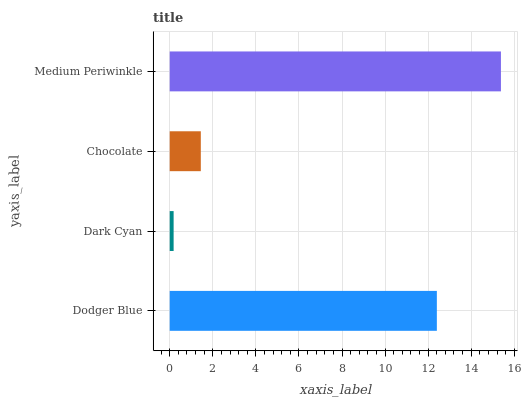Is Dark Cyan the minimum?
Answer yes or no. Yes. Is Medium Periwinkle the maximum?
Answer yes or no. Yes. Is Chocolate the minimum?
Answer yes or no. No. Is Chocolate the maximum?
Answer yes or no. No. Is Chocolate greater than Dark Cyan?
Answer yes or no. Yes. Is Dark Cyan less than Chocolate?
Answer yes or no. Yes. Is Dark Cyan greater than Chocolate?
Answer yes or no. No. Is Chocolate less than Dark Cyan?
Answer yes or no. No. Is Dodger Blue the high median?
Answer yes or no. Yes. Is Chocolate the low median?
Answer yes or no. Yes. Is Dark Cyan the high median?
Answer yes or no. No. Is Medium Periwinkle the low median?
Answer yes or no. No. 